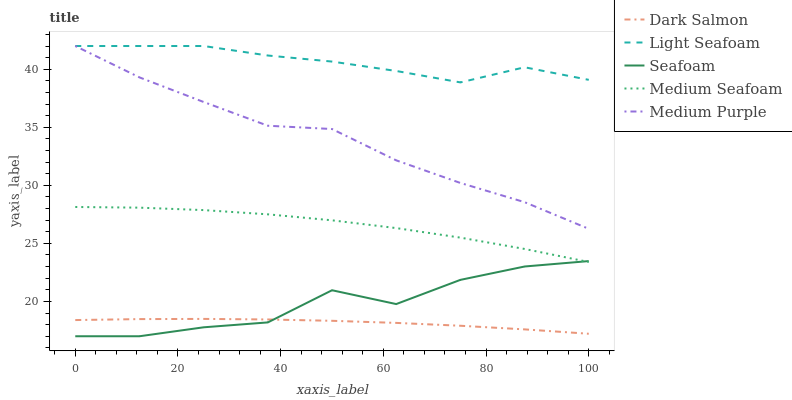Does Dark Salmon have the minimum area under the curve?
Answer yes or no. Yes. Does Light Seafoam have the maximum area under the curve?
Answer yes or no. Yes. Does Medium Seafoam have the minimum area under the curve?
Answer yes or no. No. Does Medium Seafoam have the maximum area under the curve?
Answer yes or no. No. Is Dark Salmon the smoothest?
Answer yes or no. Yes. Is Seafoam the roughest?
Answer yes or no. Yes. Is Medium Seafoam the smoothest?
Answer yes or no. No. Is Medium Seafoam the roughest?
Answer yes or no. No. Does Seafoam have the lowest value?
Answer yes or no. Yes. Does Medium Seafoam have the lowest value?
Answer yes or no. No. Does Light Seafoam have the highest value?
Answer yes or no. Yes. Does Medium Seafoam have the highest value?
Answer yes or no. No. Is Dark Salmon less than Medium Purple?
Answer yes or no. Yes. Is Medium Seafoam greater than Dark Salmon?
Answer yes or no. Yes. Does Seafoam intersect Medium Seafoam?
Answer yes or no. Yes. Is Seafoam less than Medium Seafoam?
Answer yes or no. No. Is Seafoam greater than Medium Seafoam?
Answer yes or no. No. Does Dark Salmon intersect Medium Purple?
Answer yes or no. No. 